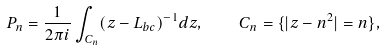Convert formula to latex. <formula><loc_0><loc_0><loc_500><loc_500>P _ { n } = \frac { 1 } { 2 \pi i } \int _ { C _ { n } } ( z - L _ { b c } ) ^ { - 1 } d z , \quad C _ { n } = \{ | z - n ^ { 2 } | = n \} ,</formula> 